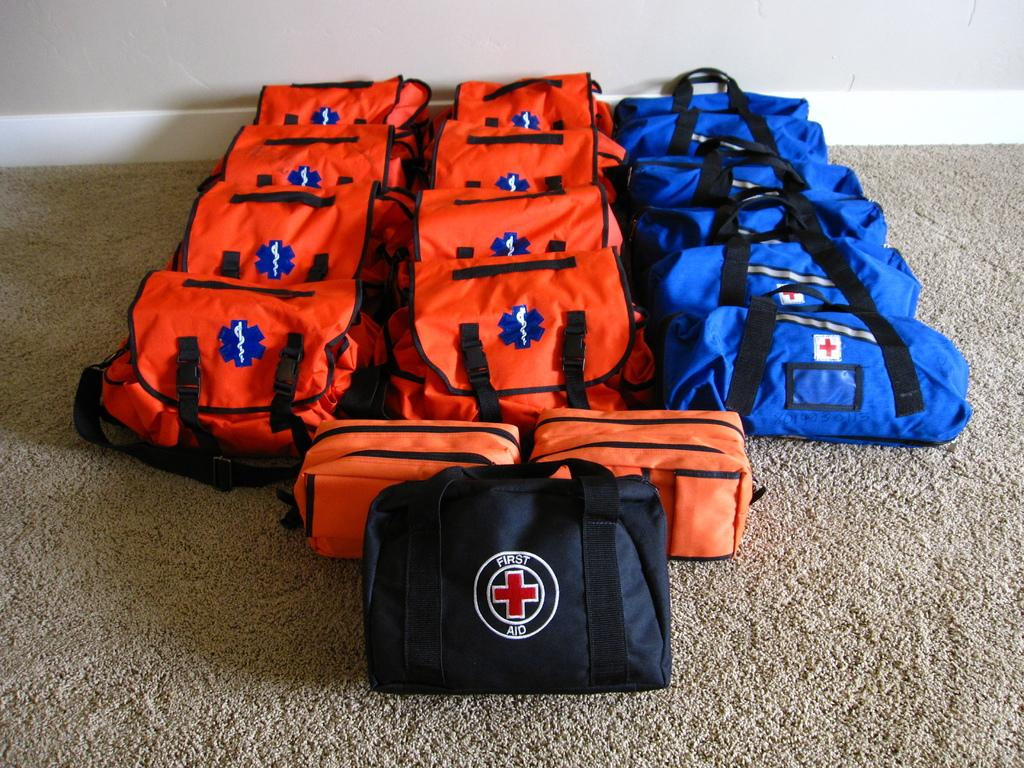What type of bags are present in the image? There are first aid bags in the image. What colors are the first aid bags? The first aid bags are in blue and orange colors. How many kittens are playing with a pen in the image? There are no kittens or pens present in the image; it only features first aid bags in blue and orange colors. 